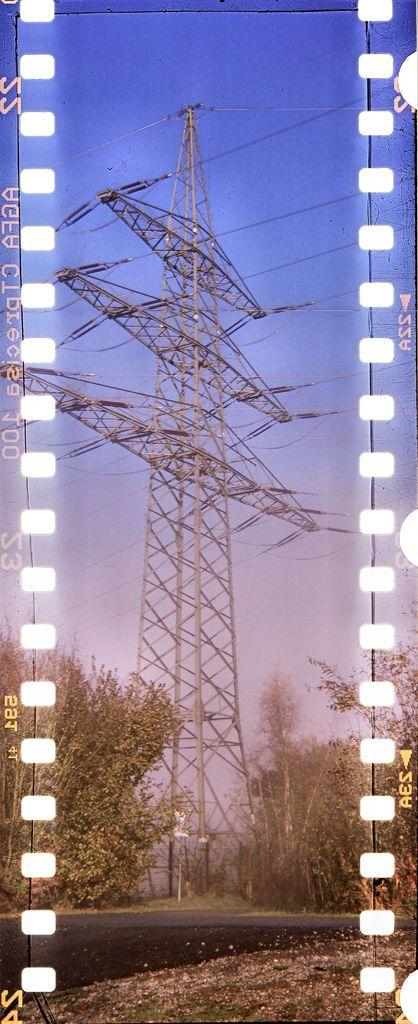What type of image is this? The image is an edited picture. What can be seen in the image besides the edited elements? There is a cellphone tower, cables, trees, and the sky visible in the image. What might be used for transmitting signals in the image? The cellphone tower in the image might be used for transmitting signals. What type of vegetation is present in the image? There are trees in the image. What is visible in the background of the image? The sky is visible in the background of the image. Are there any textual elements in the image? Yes, there are words and numbers on the image. Can you see any roots growing from the cellphone tower in the image? There are no roots visible in the image, as it features a cellphone tower, cables, trees, and the sky. How does the earthquake affect the cellphone tower in the image? There is no earthquake present in the image, so its effects cannot be determined. 